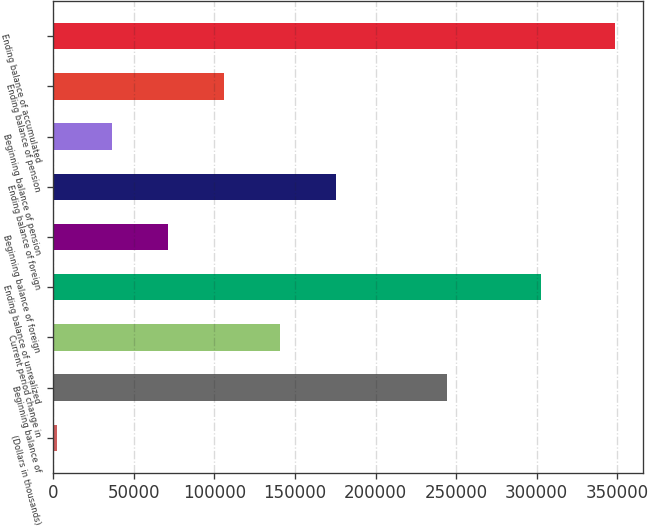Convert chart to OTSL. <chart><loc_0><loc_0><loc_500><loc_500><bar_chart><fcel>(Dollars in thousands)<fcel>Beginning balance of<fcel>Current period change in<fcel>Ending balance of unrealized<fcel>Beginning balance of foreign<fcel>Ending balance of foreign<fcel>Beginning balance of pension<fcel>Ending balance of pension<fcel>Ending balance of accumulated<nl><fcel>2006<fcel>244582<fcel>140621<fcel>302856<fcel>71313.4<fcel>175274<fcel>36659.7<fcel>105967<fcel>348543<nl></chart> 